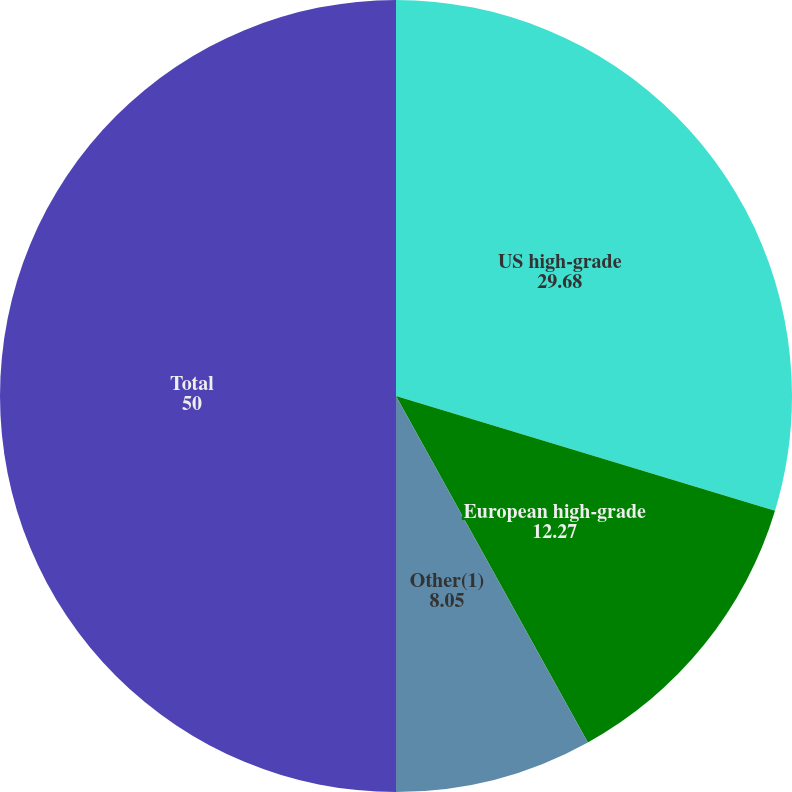Convert chart to OTSL. <chart><loc_0><loc_0><loc_500><loc_500><pie_chart><fcel>US high-grade<fcel>European high-grade<fcel>Other(1)<fcel>Total<nl><fcel>29.68%<fcel>12.27%<fcel>8.05%<fcel>50.0%<nl></chart> 